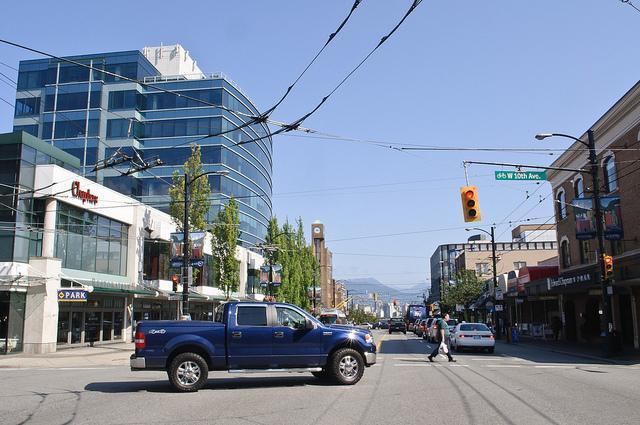How many umbrellas are pictured?
Give a very brief answer. 0. 